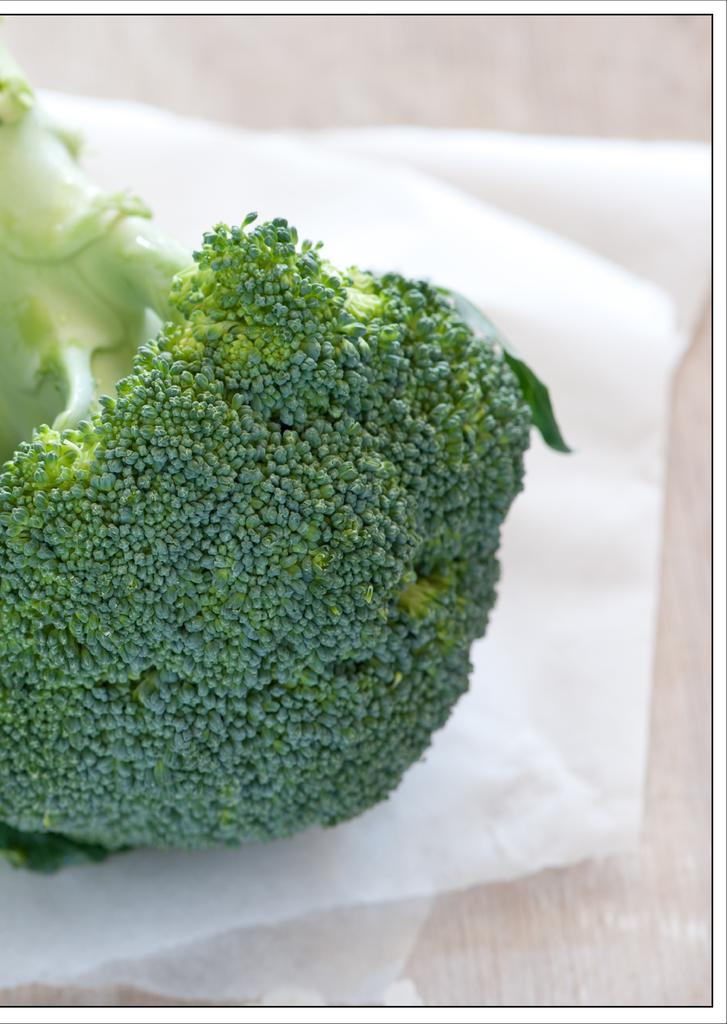What type of vegetable is in the image? There is a broccoli in the image. Where is the broccoli placed? The broccoli is on a paper. What type of net is being used for the discussion in the image? There is no net or discussion present in the image; it only features a broccoli on a paper. 